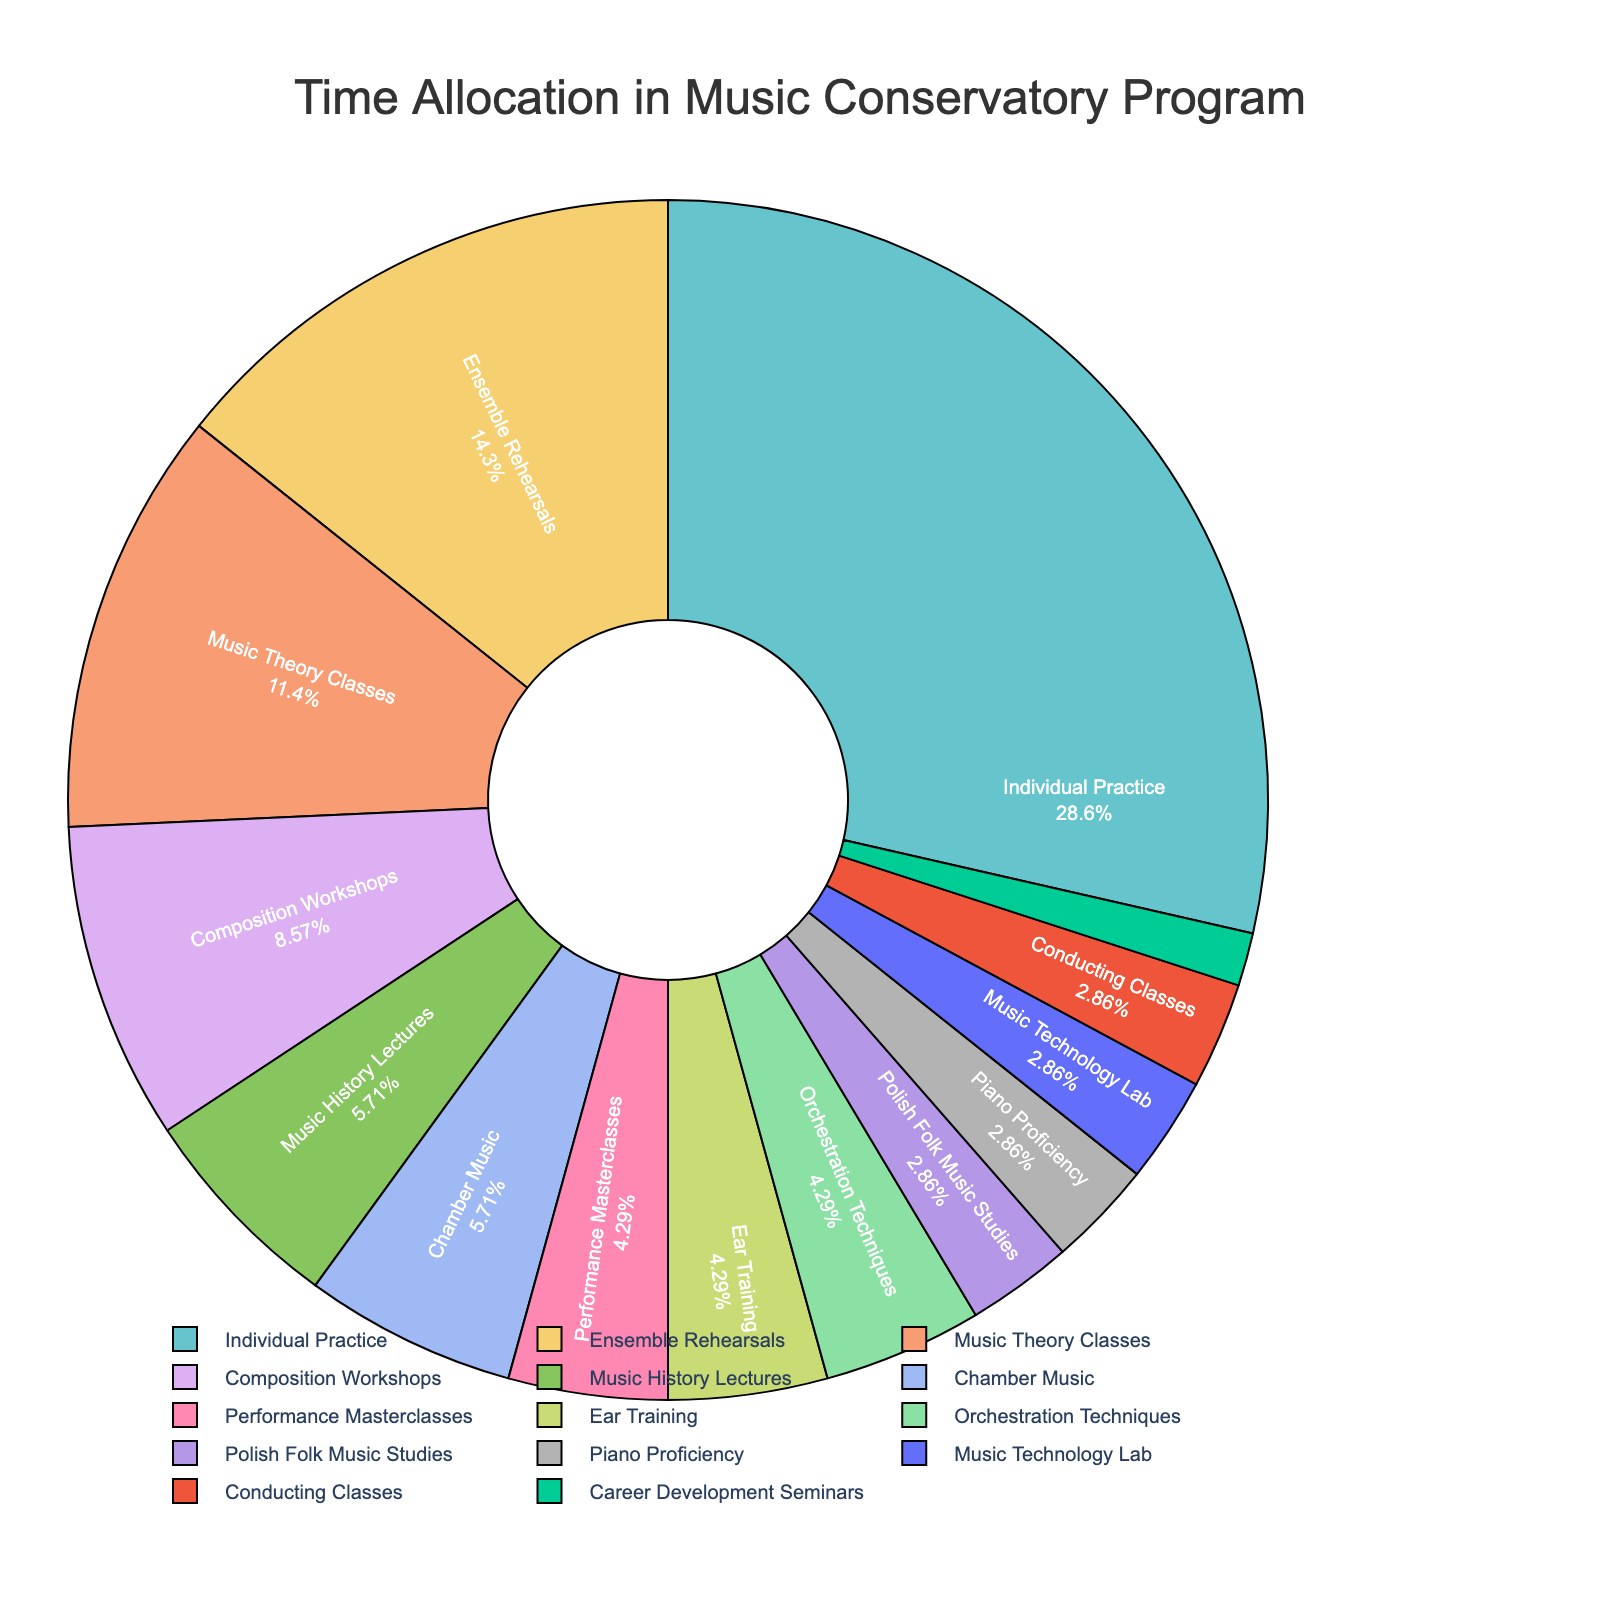what is the activity with the highest percentage of time allocation? Looking at the pie chart, the largest segment should correspond to the activity with the highest percentage. Identify the activity labeled with the biggest slice.
Answer: Individual Practice what is the combined percentage of time allocation for Music Theory Classes and Music History Lectures? Find the slices corresponding to “Music Theory Classes” and “Music History Lectures,” then add their percentages.
Answer: 8% + 4% = 12% which activity has a greater time allocation: Performance Masterclasses or Orchestration Techniques? Locate the segments for both activities and compare their percentages visually.
Answer: Orchestration Techniques how much more time is allocated to Ensemble Rehearsals compared to Chamber Music? Find the percentage for both activities and subtract the smaller percentage from the larger one to get the difference.
Answer: 10% - 4% = 6% what is the median value of the hours allocated to all activities? List all hours, sort them, and find the middle value. Hours: [1, 2, 2, 2, 2, 3, 3, 4, 4, 6, 8, 10, 20], Median is the middle value when sorted.
Answer: 3 which activity takes up equally 3% of the weekly hours? Identify segments that display 3% next to their labels.
Answer: Performance Masterclasses, Ear Training, Orchestration Techniques is the time allocation for Composition Workshops more or less than twice that of Music Technology Lab? Compare the percentage for Composition Workshops with twice the percentage for Music Technology Lab by visually inspecting the slices.
Answer: Composition Workshops is more how much time in total is allocated to activities with exactly 2 hours per week? Locate all activities with 2 hours and sum up their percentages.
Answer: Polish Folk Music Studies, Piano Proficiency, Music Technology Lab, Conducting Classes: 2% + 2% + 2% + 2% = 8% considering only Individual Practice and Ensemble Rehearsals, what fraction of total time do they occupy? Sum up the hours for Individual Practice and Ensemble Rehearsals and divide by the total weekly hours (67).
Answer: (20+10)/67 = 30/67 ≈ 0.4485 which activity has the smallest time allocation and what is its percentage? Identify the smallest slice on the pie chart and note its label and percentage.
Answer: Career Development Seminars, 1% 